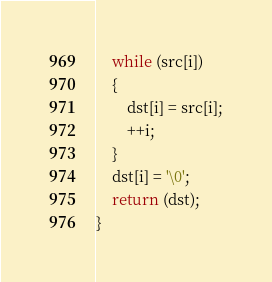Convert code to text. <code><loc_0><loc_0><loc_500><loc_500><_C_>	while (src[i])
	{
		dst[i] = src[i];
		++i;
	}
	dst[i] = '\0';
	return (dst);
}
</code> 